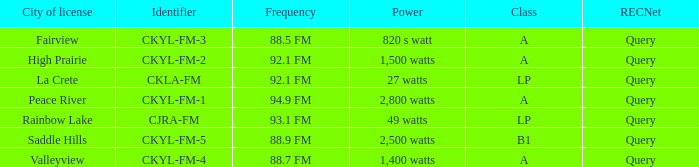What is the identifier with 94.9 fm frequency CKYL-FM-1. 